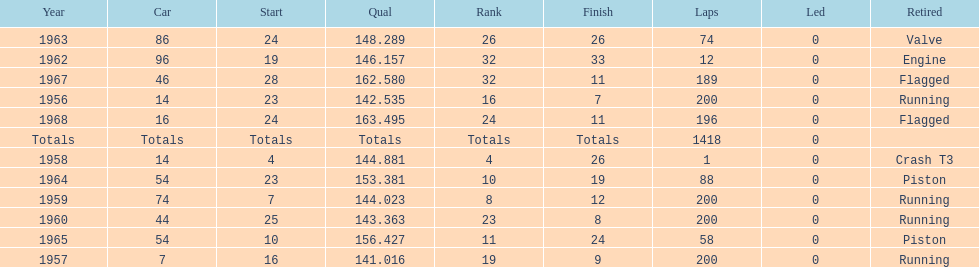What year did he have the same number car as 1964? 1965. Would you be able to parse every entry in this table? {'header': ['Year', 'Car', 'Start', 'Qual', 'Rank', 'Finish', 'Laps', 'Led', 'Retired'], 'rows': [['1963', '86', '24', '148.289', '26', '26', '74', '0', 'Valve'], ['1962', '96', '19', '146.157', '32', '33', '12', '0', 'Engine'], ['1967', '46', '28', '162.580', '32', '11', '189', '0', 'Flagged'], ['1956', '14', '23', '142.535', '16', '7', '200', '0', 'Running'], ['1968', '16', '24', '163.495', '24', '11', '196', '0', 'Flagged'], ['Totals', 'Totals', 'Totals', 'Totals', 'Totals', 'Totals', '1418', '0', ''], ['1958', '14', '4', '144.881', '4', '26', '1', '0', 'Crash T3'], ['1964', '54', '23', '153.381', '10', '19', '88', '0', 'Piston'], ['1959', '74', '7', '144.023', '8', '12', '200', '0', 'Running'], ['1960', '44', '25', '143.363', '23', '8', '200', '0', 'Running'], ['1965', '54', '10', '156.427', '11', '24', '58', '0', 'Piston'], ['1957', '7', '16', '141.016', '19', '9', '200', '0', 'Running']]} 